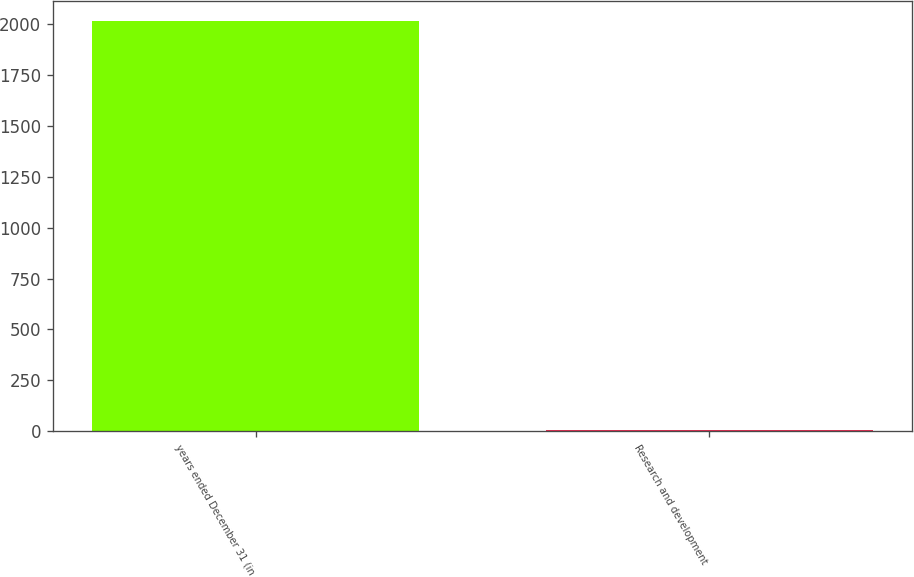Convert chart to OTSL. <chart><loc_0><loc_0><loc_500><loc_500><bar_chart><fcel>years ended December 31 (in<fcel>Research and development<nl><fcel>2012<fcel>6<nl></chart> 